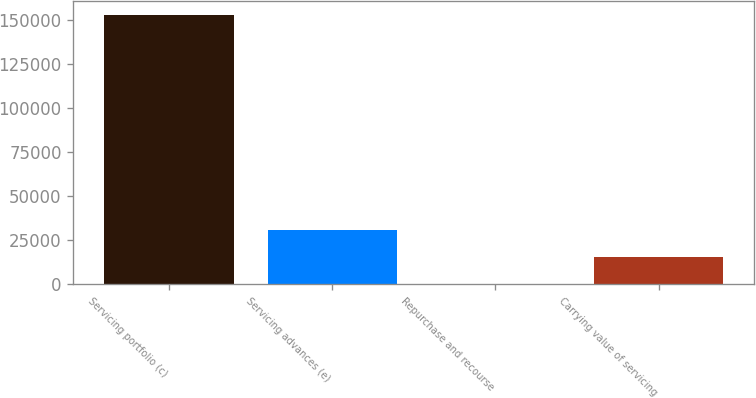Convert chart. <chart><loc_0><loc_0><loc_500><loc_500><bar_chart><fcel>Servicing portfolio (c)<fcel>Servicing advances (e)<fcel>Repurchase and recourse<fcel>Carrying value of servicing<nl><fcel>153193<fcel>30673<fcel>43<fcel>15358<nl></chart> 